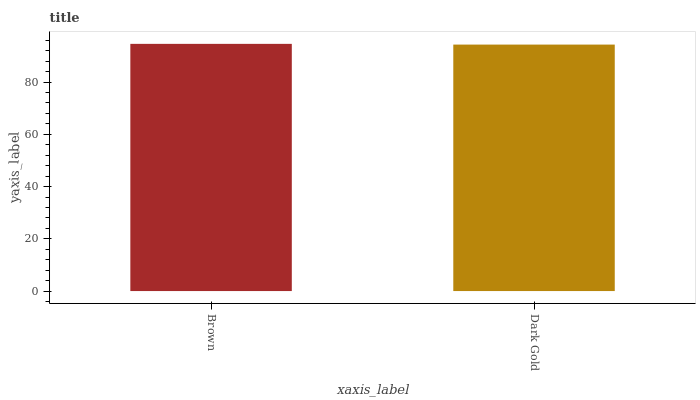Is Dark Gold the minimum?
Answer yes or no. Yes. Is Brown the maximum?
Answer yes or no. Yes. Is Dark Gold the maximum?
Answer yes or no. No. Is Brown greater than Dark Gold?
Answer yes or no. Yes. Is Dark Gold less than Brown?
Answer yes or no. Yes. Is Dark Gold greater than Brown?
Answer yes or no. No. Is Brown less than Dark Gold?
Answer yes or no. No. Is Brown the high median?
Answer yes or no. Yes. Is Dark Gold the low median?
Answer yes or no. Yes. Is Dark Gold the high median?
Answer yes or no. No. Is Brown the low median?
Answer yes or no. No. 